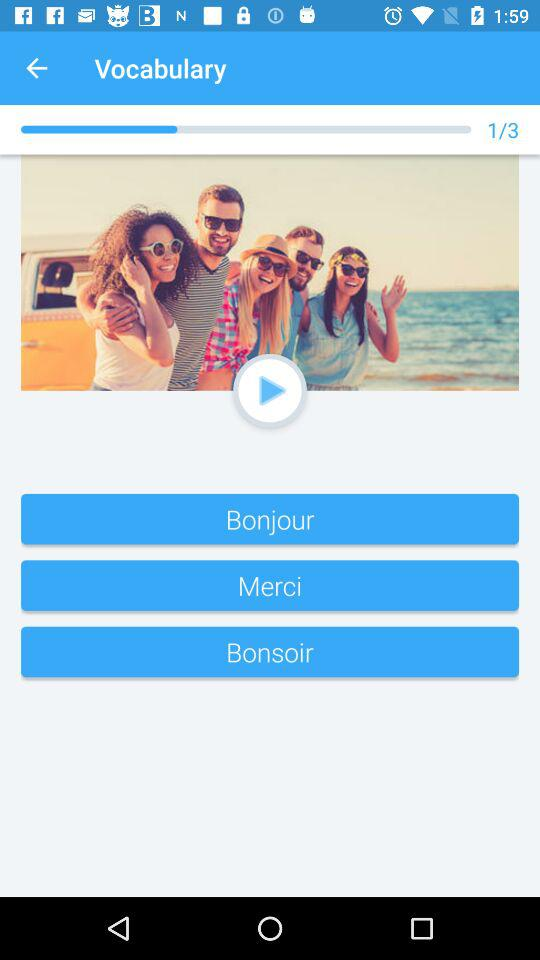How many people are standing in front of the van?
Answer the question using a single word or phrase. 5 